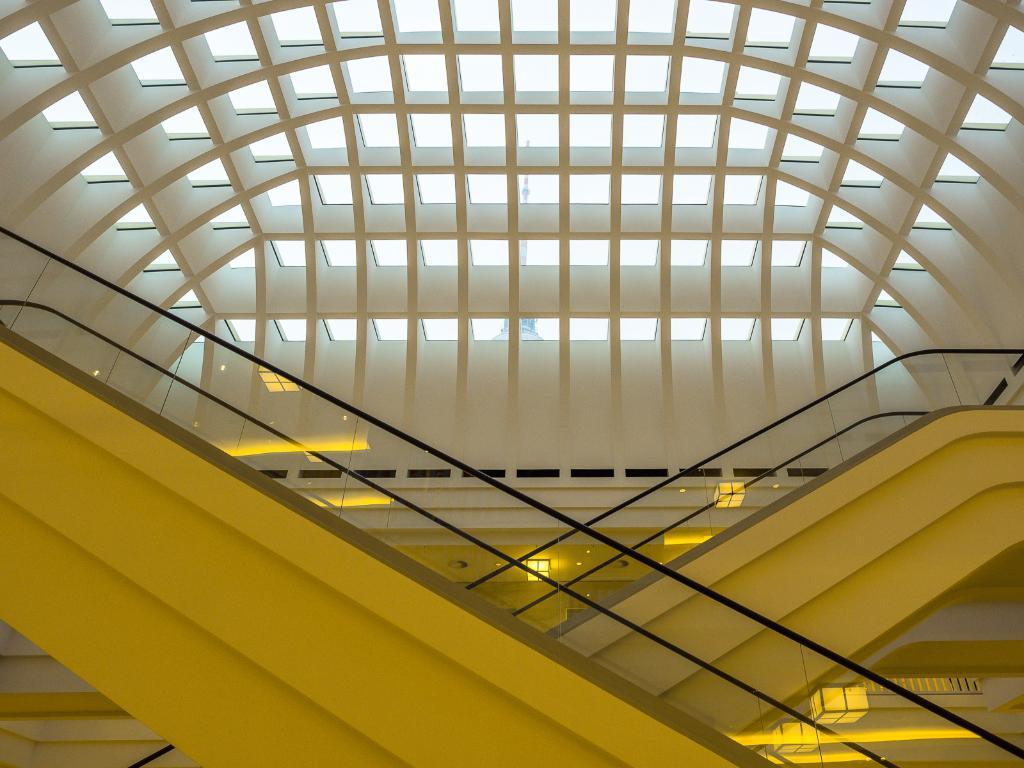Where was the image taken? The image was taken inside a building. What can be seen in the center of the image? There are staircases in the center of the image. What is visible in the background of the image? There is a wall visible in the image. What type of jam is being spread on the sister's sandwich in the image? There is no sister or sandwich present in the image, so it is not possible to determine what type of jam might be spread on a sandwich. 